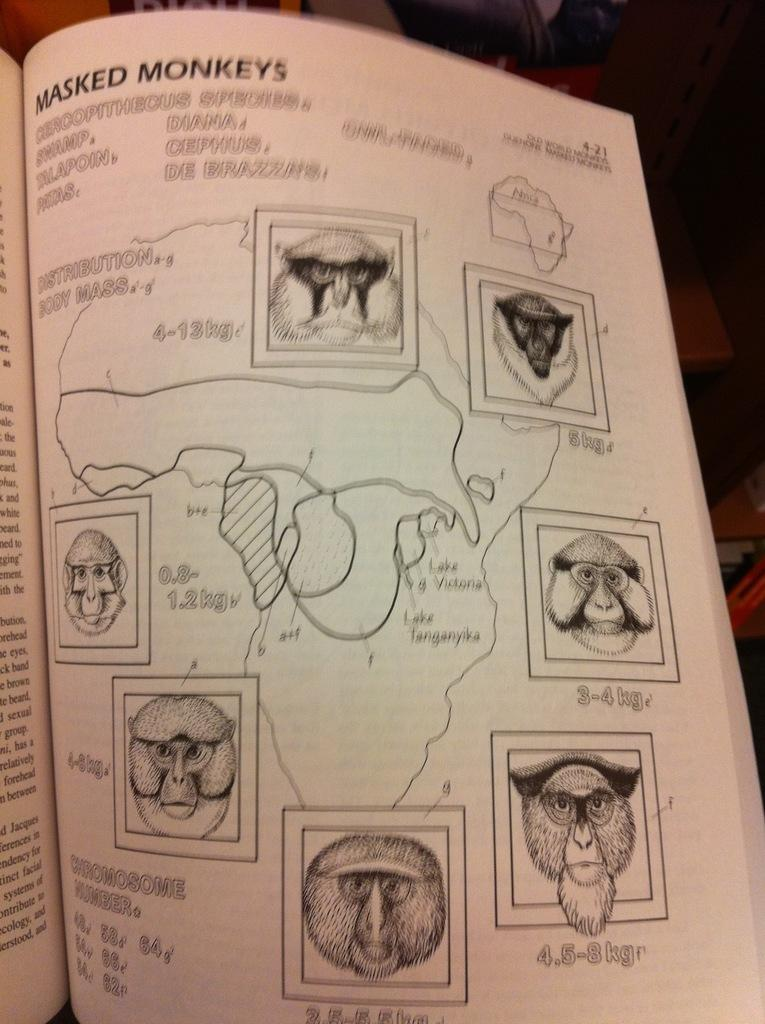What object can be seen in the image that people typically use for reading? There is a book in the image that people typically use for reading. What type of furniture is present in the image that people might sit on? There is a chair in the image that people might sit on. What type of furniture is present in the image that people might place objects on? There is a table in the image that people might place objects on. What can be found within the pages of the book in the image? The book contains depictions of animals. What type of music is being played on the record in the image? There is no record present in the image; it only contains a book, chair, and table. How many sisters are visible in the image? There are no people, including sisters, present in the image. 